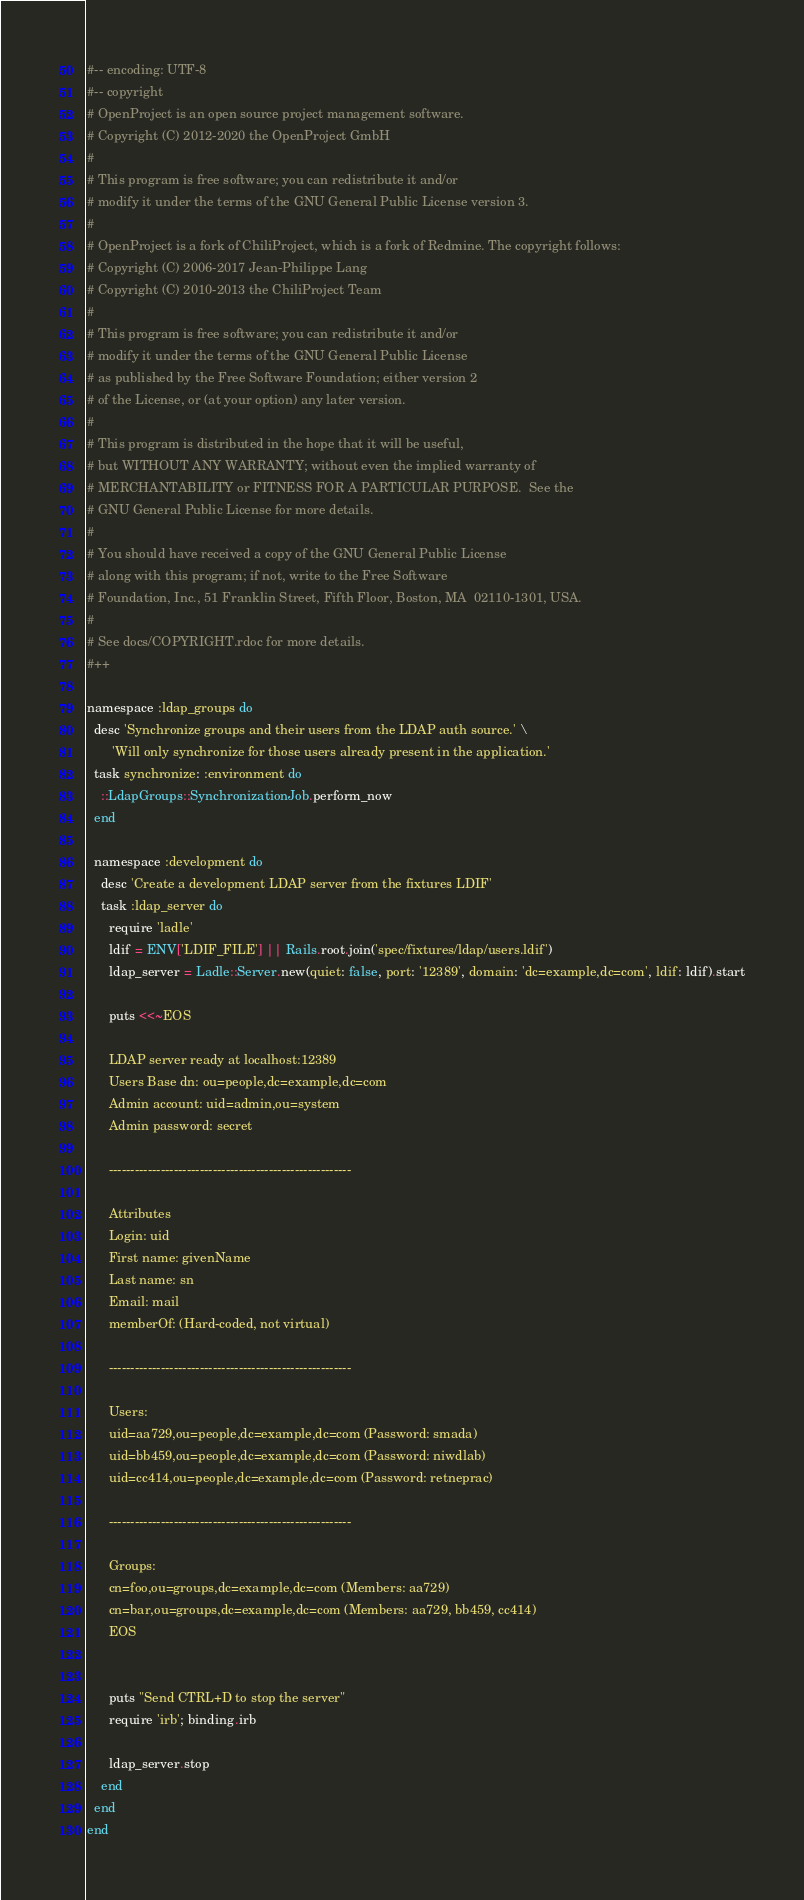<code> <loc_0><loc_0><loc_500><loc_500><_Ruby_>#-- encoding: UTF-8
#-- copyright
# OpenProject is an open source project management software.
# Copyright (C) 2012-2020 the OpenProject GmbH
#
# This program is free software; you can redistribute it and/or
# modify it under the terms of the GNU General Public License version 3.
#
# OpenProject is a fork of ChiliProject, which is a fork of Redmine. The copyright follows:
# Copyright (C) 2006-2017 Jean-Philippe Lang
# Copyright (C) 2010-2013 the ChiliProject Team
#
# This program is free software; you can redistribute it and/or
# modify it under the terms of the GNU General Public License
# as published by the Free Software Foundation; either version 2
# of the License, or (at your option) any later version.
#
# This program is distributed in the hope that it will be useful,
# but WITHOUT ANY WARRANTY; without even the implied warranty of
# MERCHANTABILITY or FITNESS FOR A PARTICULAR PURPOSE.  See the
# GNU General Public License for more details.
#
# You should have received a copy of the GNU General Public License
# along with this program; if not, write to the Free Software
# Foundation, Inc., 51 Franklin Street, Fifth Floor, Boston, MA  02110-1301, USA.
#
# See docs/COPYRIGHT.rdoc for more details.
#++

namespace :ldap_groups do
  desc 'Synchronize groups and their users from the LDAP auth source.' \
       'Will only synchronize for those users already present in the application.'
  task synchronize: :environment do
    ::LdapGroups::SynchronizationJob.perform_now
  end

  namespace :development do
    desc 'Create a development LDAP server from the fixtures LDIF'
    task :ldap_server do
      require 'ladle'
      ldif = ENV['LDIF_FILE'] || Rails.root.join('spec/fixtures/ldap/users.ldif')
      ldap_server = Ladle::Server.new(quiet: false, port: '12389', domain: 'dc=example,dc=com', ldif: ldif).start

      puts <<~EOS
      
      LDAP server ready at localhost:12389
      Users Base dn: ou=people,dc=example,dc=com
      Admin account: uid=admin,ou=system
      Admin password: secret

      --------------------------------------------------------

      Attributes
      Login: uid
      First name: givenName
      Last name: sn
      Email: mail
      memberOf: (Hard-coded, not virtual)

      --------------------------------------------------------
        
      Users:
      uid=aa729,ou=people,dc=example,dc=com (Password: smada)
      uid=bb459,ou=people,dc=example,dc=com (Password: niwdlab)
      uid=cc414,ou=people,dc=example,dc=com (Password: retneprac)

      --------------------------------------------------------

      Groups:
      cn=foo,ou=groups,dc=example,dc=com (Members: aa729)
      cn=bar,ou=groups,dc=example,dc=com (Members: aa729, bb459, cc414)
      EOS


      puts "Send CTRL+D to stop the server"
      require 'irb'; binding.irb

      ldap_server.stop
    end
  end
end
</code> 